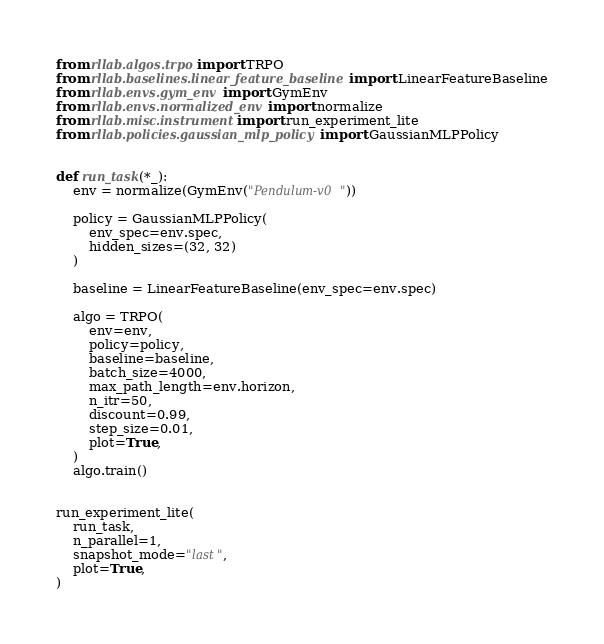<code> <loc_0><loc_0><loc_500><loc_500><_Python_>from rllab.algos.trpo import TRPO
from rllab.baselines.linear_feature_baseline import LinearFeatureBaseline
from rllab.envs.gym_env import GymEnv
from rllab.envs.normalized_env import normalize
from rllab.misc.instrument import run_experiment_lite
from rllab.policies.gaussian_mlp_policy import GaussianMLPPolicy


def run_task(*_):
    env = normalize(GymEnv("Pendulum-v0"))

    policy = GaussianMLPPolicy(
        env_spec=env.spec,
        hidden_sizes=(32, 32)
    )

    baseline = LinearFeatureBaseline(env_spec=env.spec)

    algo = TRPO(
        env=env,
        policy=policy,
        baseline=baseline,
        batch_size=4000,
        max_path_length=env.horizon,
        n_itr=50,
        discount=0.99,
        step_size=0.01,
        plot=True,
    )
    algo.train()


run_experiment_lite(
    run_task,
    n_parallel=1,
    snapshot_mode="last",
    plot=True,
)
</code> 